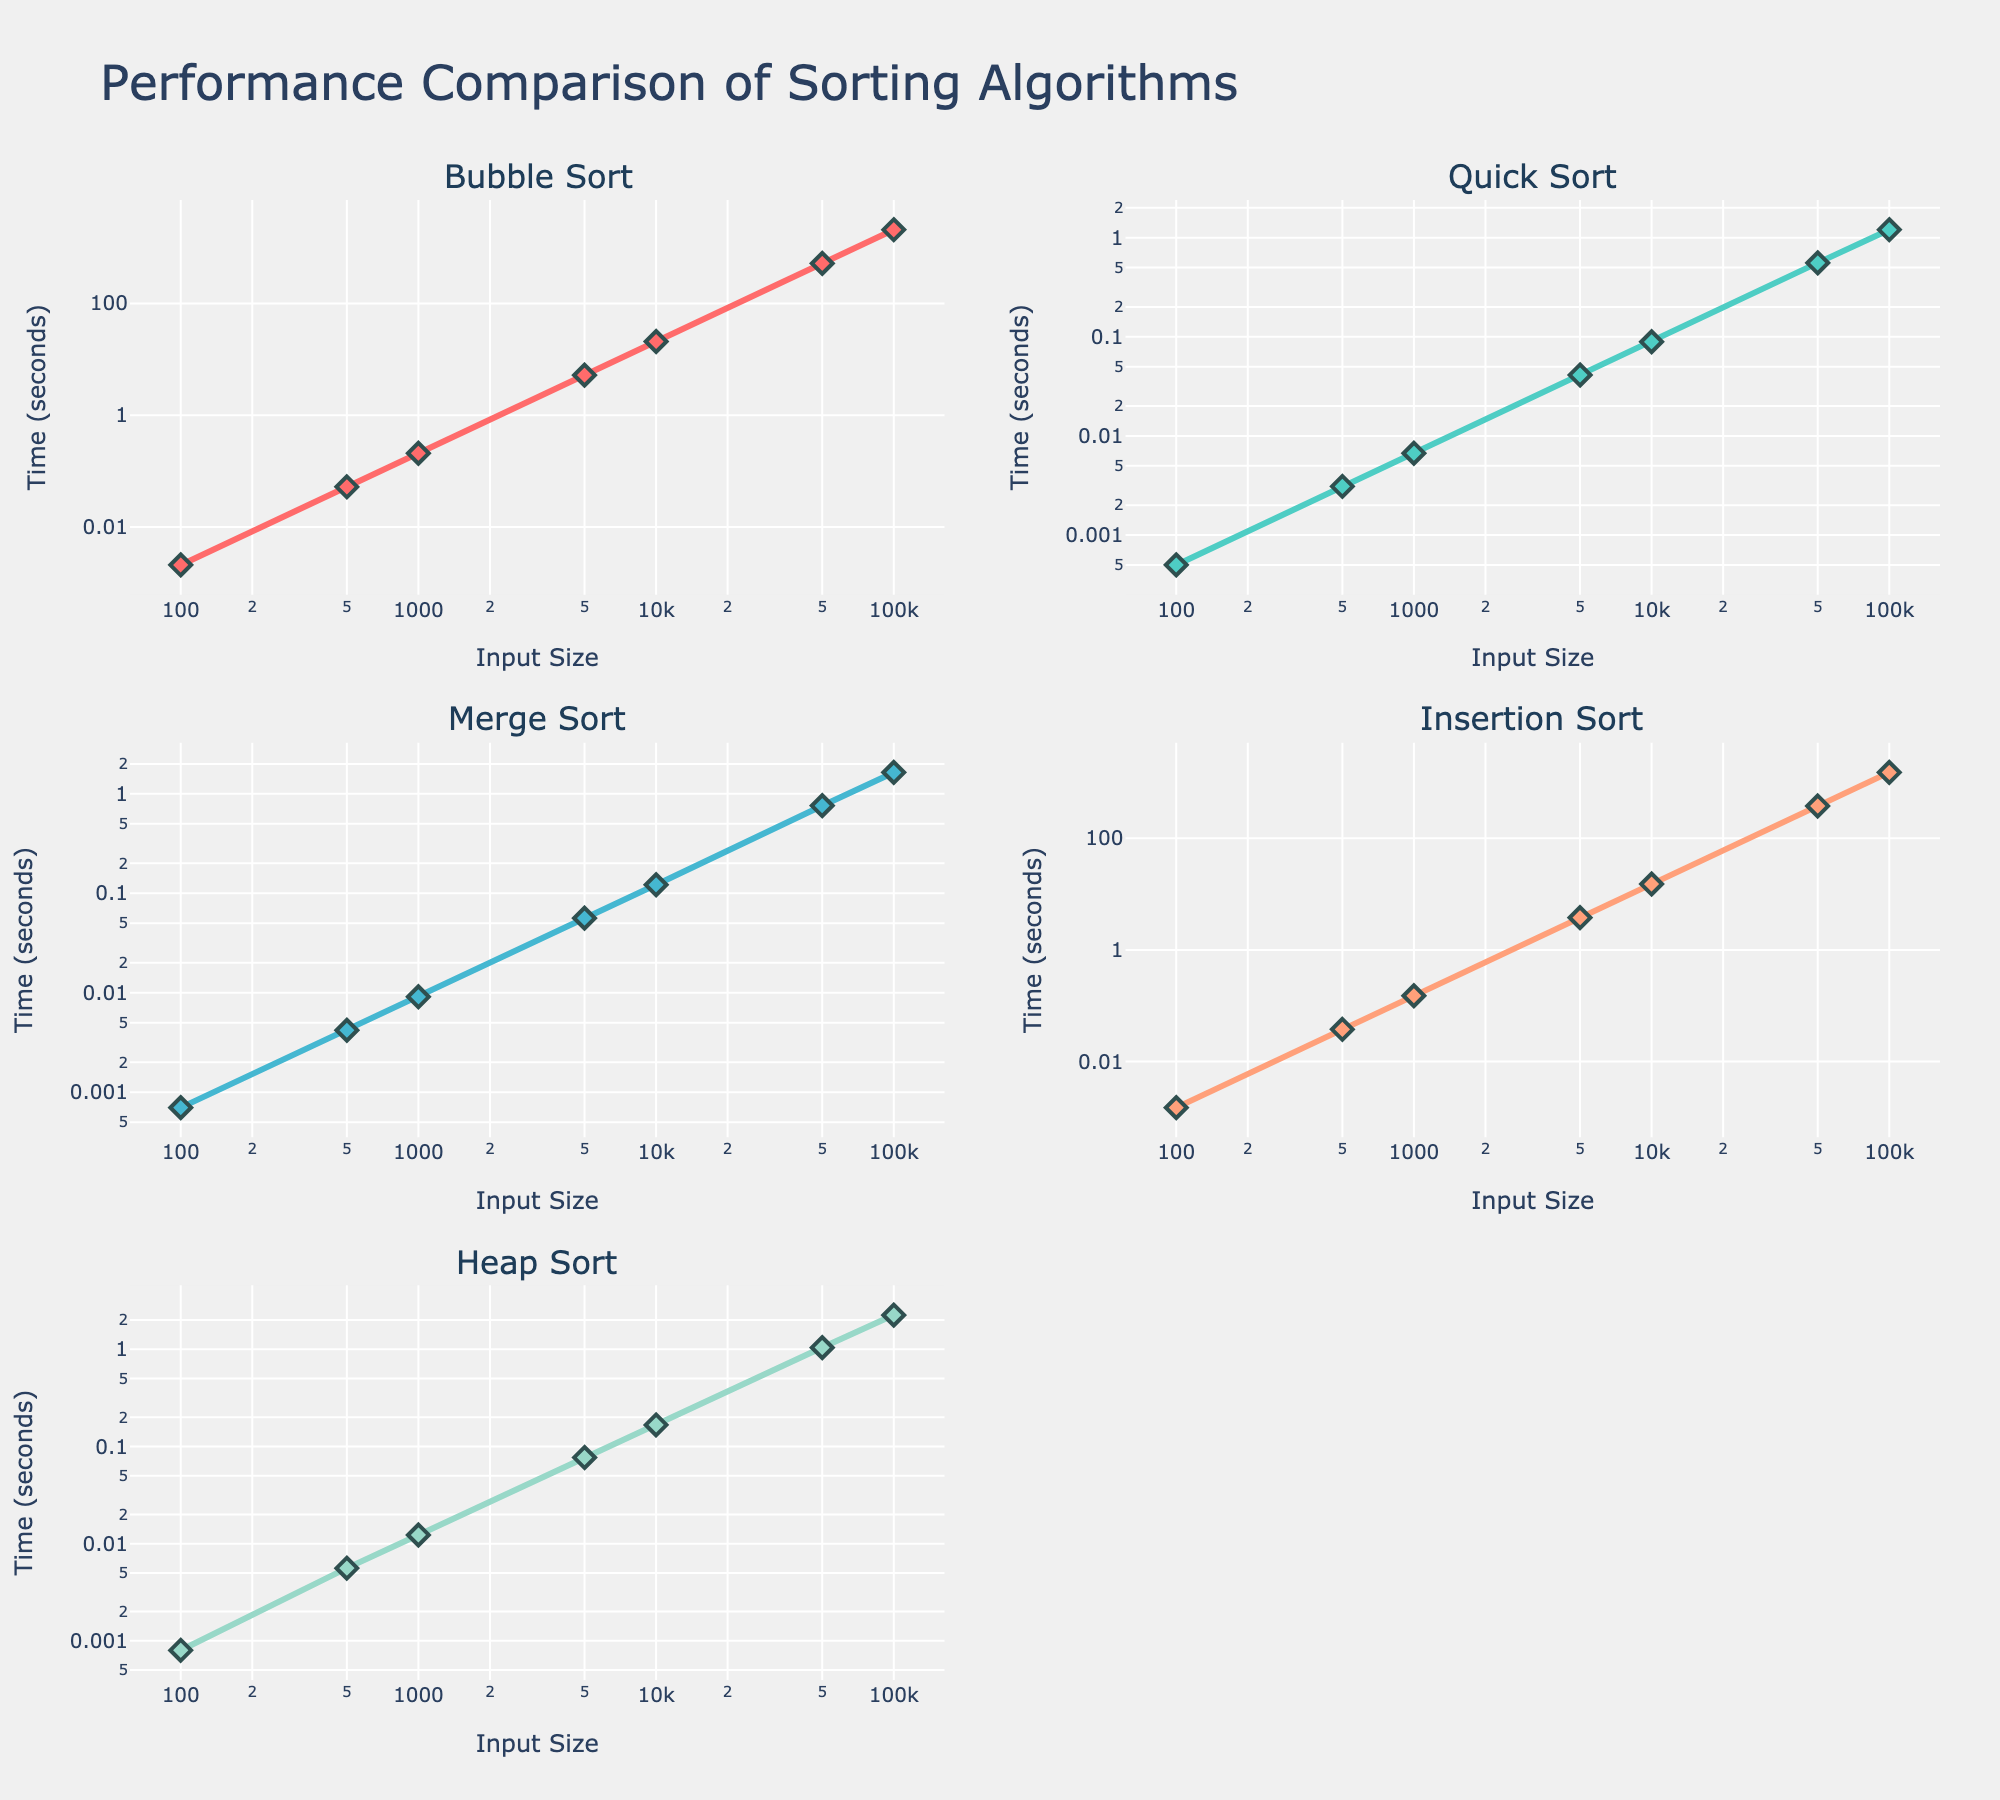What's the title of the figure? The title of the figure is located at the top center. It reads "Performance Comparison of Sorting Algorithms".
Answer: "Performance Comparison of Sorting Algorithms" How many sorting algorithms are being compared in the figure? Each subplot corresponds to a different sorting algorithm. There are five subplots, indicating five sorting algorithms.
Answer: Five What's the color used for the Quick Sort line? The Quick Sort line is the second subplot in the grid. The color used for the Quick Sort line is a shade of turquoise.
Answer: Turquoise Which subplot corresponds to the Heap Sort algorithm? Each subplot title names the sorting algorithm it represents. The Heap Sort algorithm corresponds to the subplot in the third row, first column.
Answer: Third row, first column Which sorting algorithm shows the highest execution time for an input size of 100000? Look for the highest y-value in the plot corresponding to the input size of 100000. The Bubble Sort plot has the highest y-value at that input size.
Answer: Bubble Sort Is the execution time for Merge Sort greater than Quick Sort for an input size of 50000? In the subplots for Merge Sort and Quick Sort, compare the y-values for an input size of 50000. Merge Sort has a higher y-value than Quick Sort.
Answer: Yes, it is greater Which algorithm has the lowest execution time for an input size of 100? Check all subplots for the y-value corresponding to an input size of 100. Quick Sort has the lowest value.
Answer: Quick Sort What is the trend of execution times for Bubble Sort as the input size increases? In the Bubble Sort subplot, observe the trend of y-values as the x-values increase. The execution time increases exponentially with the input size.
Answer: Increases exponentially Compare the execution time of Heap Sort and Insertion Sort at an input size of 10000. Which one is lower? Examine the subplots for Heap Sort and Insertion Sort at the x-value of 10000. Heap Sort has a lower y-value.
Answer: Heap Sort What is the input size where Merge Sort and Heap Sort have similar execution times? Look for where the y-values of Merge Sort and Heap Sort intersect or are close to each other across different x-values. At the input size of approximately 5000, both algorithms have somewhat similar execution times.
Answer: 5000 